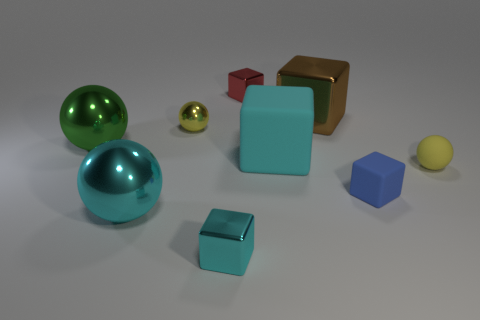There is another ball that is the same color as the small shiny sphere; what is it made of?
Ensure brevity in your answer.  Rubber. There is a object that is the same color as the matte ball; what is its size?
Your response must be concise. Small. What is the shape of the small blue matte object?
Your answer should be very brief. Cube. What is the shape of the tiny thing that is the same color as the big matte thing?
Your answer should be very brief. Cube. The large brown thing that is made of the same material as the green sphere is what shape?
Keep it short and to the point. Cube. Are there any other things that have the same material as the small red thing?
Ensure brevity in your answer.  Yes. Is the number of shiny blocks to the left of the tiny red metal block less than the number of big cyan shiny things?
Keep it short and to the point. No. Are there more tiny cyan metal cubes behind the small yellow rubber ball than brown shiny objects in front of the large cyan rubber thing?
Ensure brevity in your answer.  No. Is there any other thing of the same color as the large metal cube?
Ensure brevity in your answer.  No. What material is the yellow sphere that is to the left of the large cyan matte object?
Your response must be concise. Metal. 